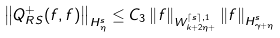Convert formula to latex. <formula><loc_0><loc_0><loc_500><loc_500>\left \| Q ^ { + } _ { R S } ( f , f ) \right \| _ { H ^ { s } _ { \eta } } \leq C _ { 3 } \left \| f \right \| _ { W ^ { \lceil s \rceil , 1 } _ { k + 2 \eta + } } \left \| f \right \| _ { H ^ { s } _ { \gamma + \eta } }</formula> 